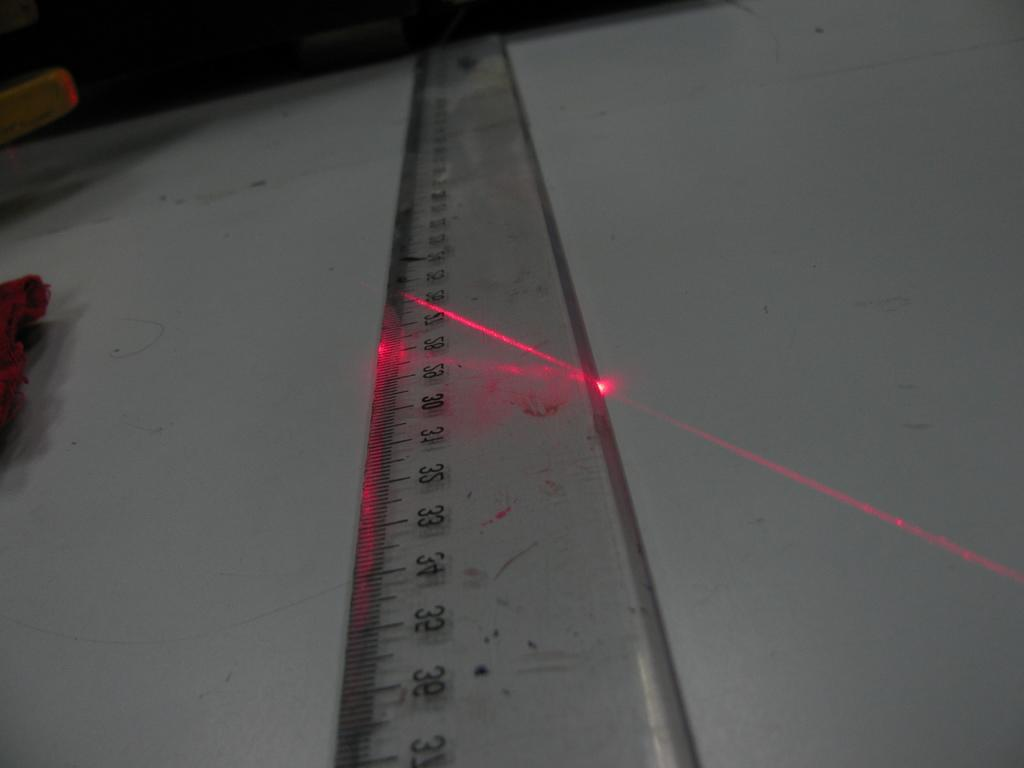What can be seen in the foreground of the image? There is a scale in the foreground of the image. What is the color of the light and the object it is on? There is a red light on a white color object. What type of object is on the left side of the image? There is a wooden object on the left side of the image. What is the color of the object on the left side of the image? There is a red color object on the left side of the image. How would you describe the lighting in the top part of the image? The top part of the image is dark. Can you see any fog in the image? There is no mention of fog in the provided facts, so it cannot be determined if there is any fog in the image. Are there any animals from a zoo present in the image? There is no mention of animals or a zoo in the provided facts, so it cannot be determined if there are any animals from a zoo in the image. 